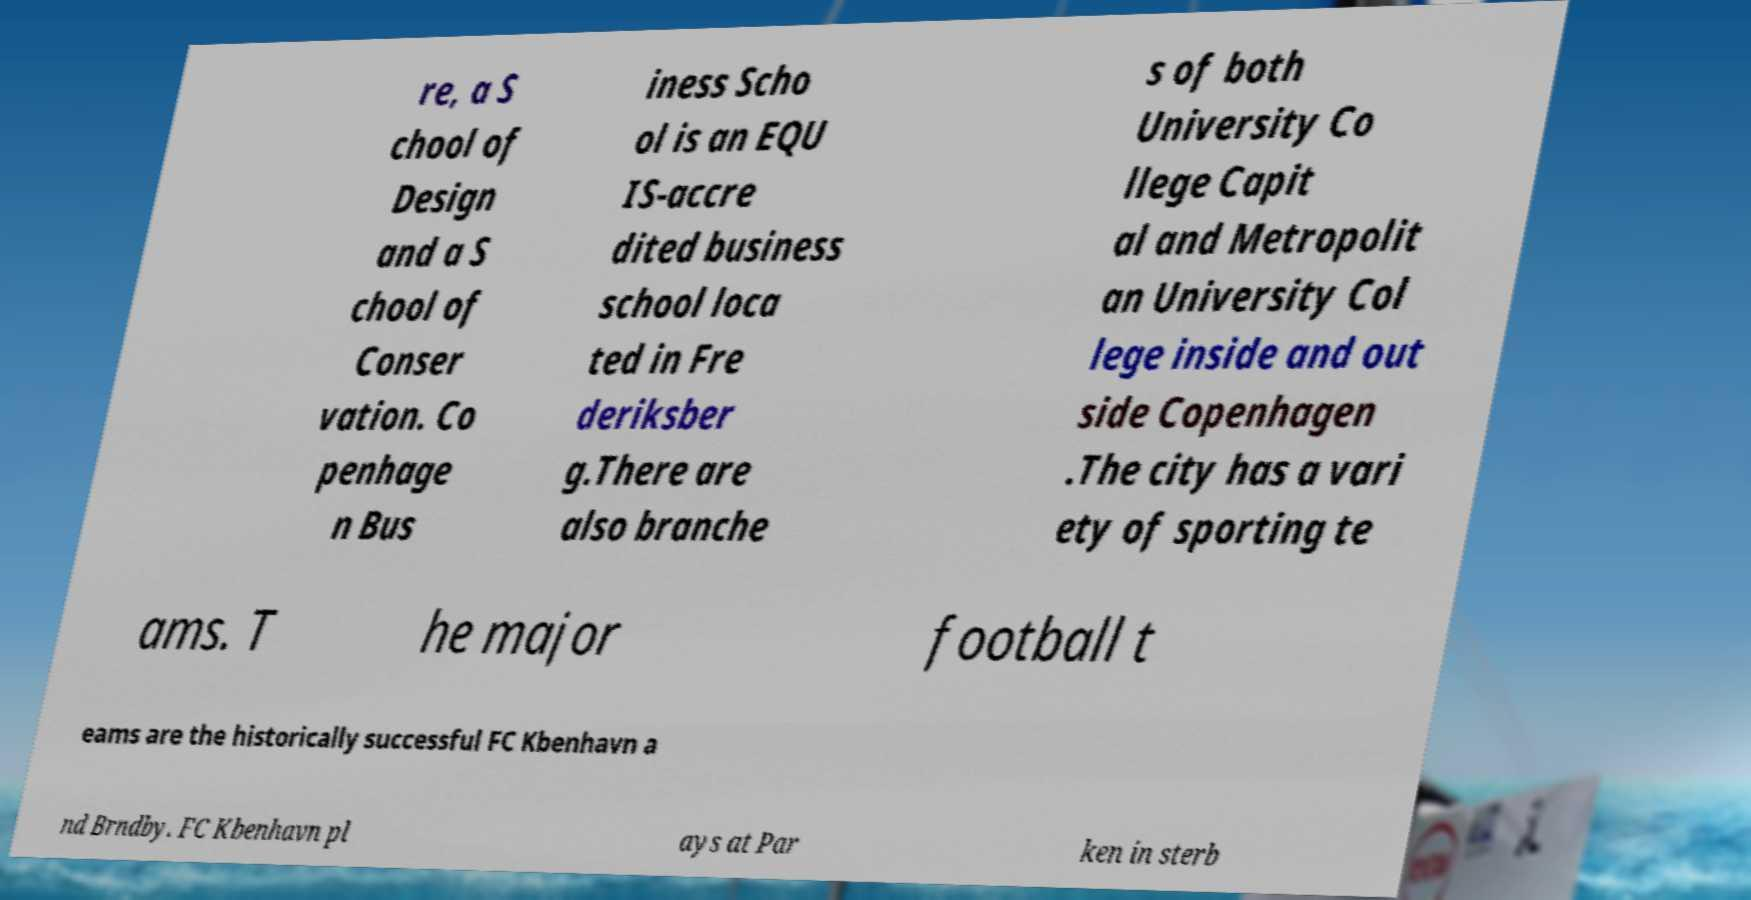Can you accurately transcribe the text from the provided image for me? re, a S chool of Design and a S chool of Conser vation. Co penhage n Bus iness Scho ol is an EQU IS-accre dited business school loca ted in Fre deriksber g.There are also branche s of both University Co llege Capit al and Metropolit an University Col lege inside and out side Copenhagen .The city has a vari ety of sporting te ams. T he major football t eams are the historically successful FC Kbenhavn a nd Brndby. FC Kbenhavn pl ays at Par ken in sterb 